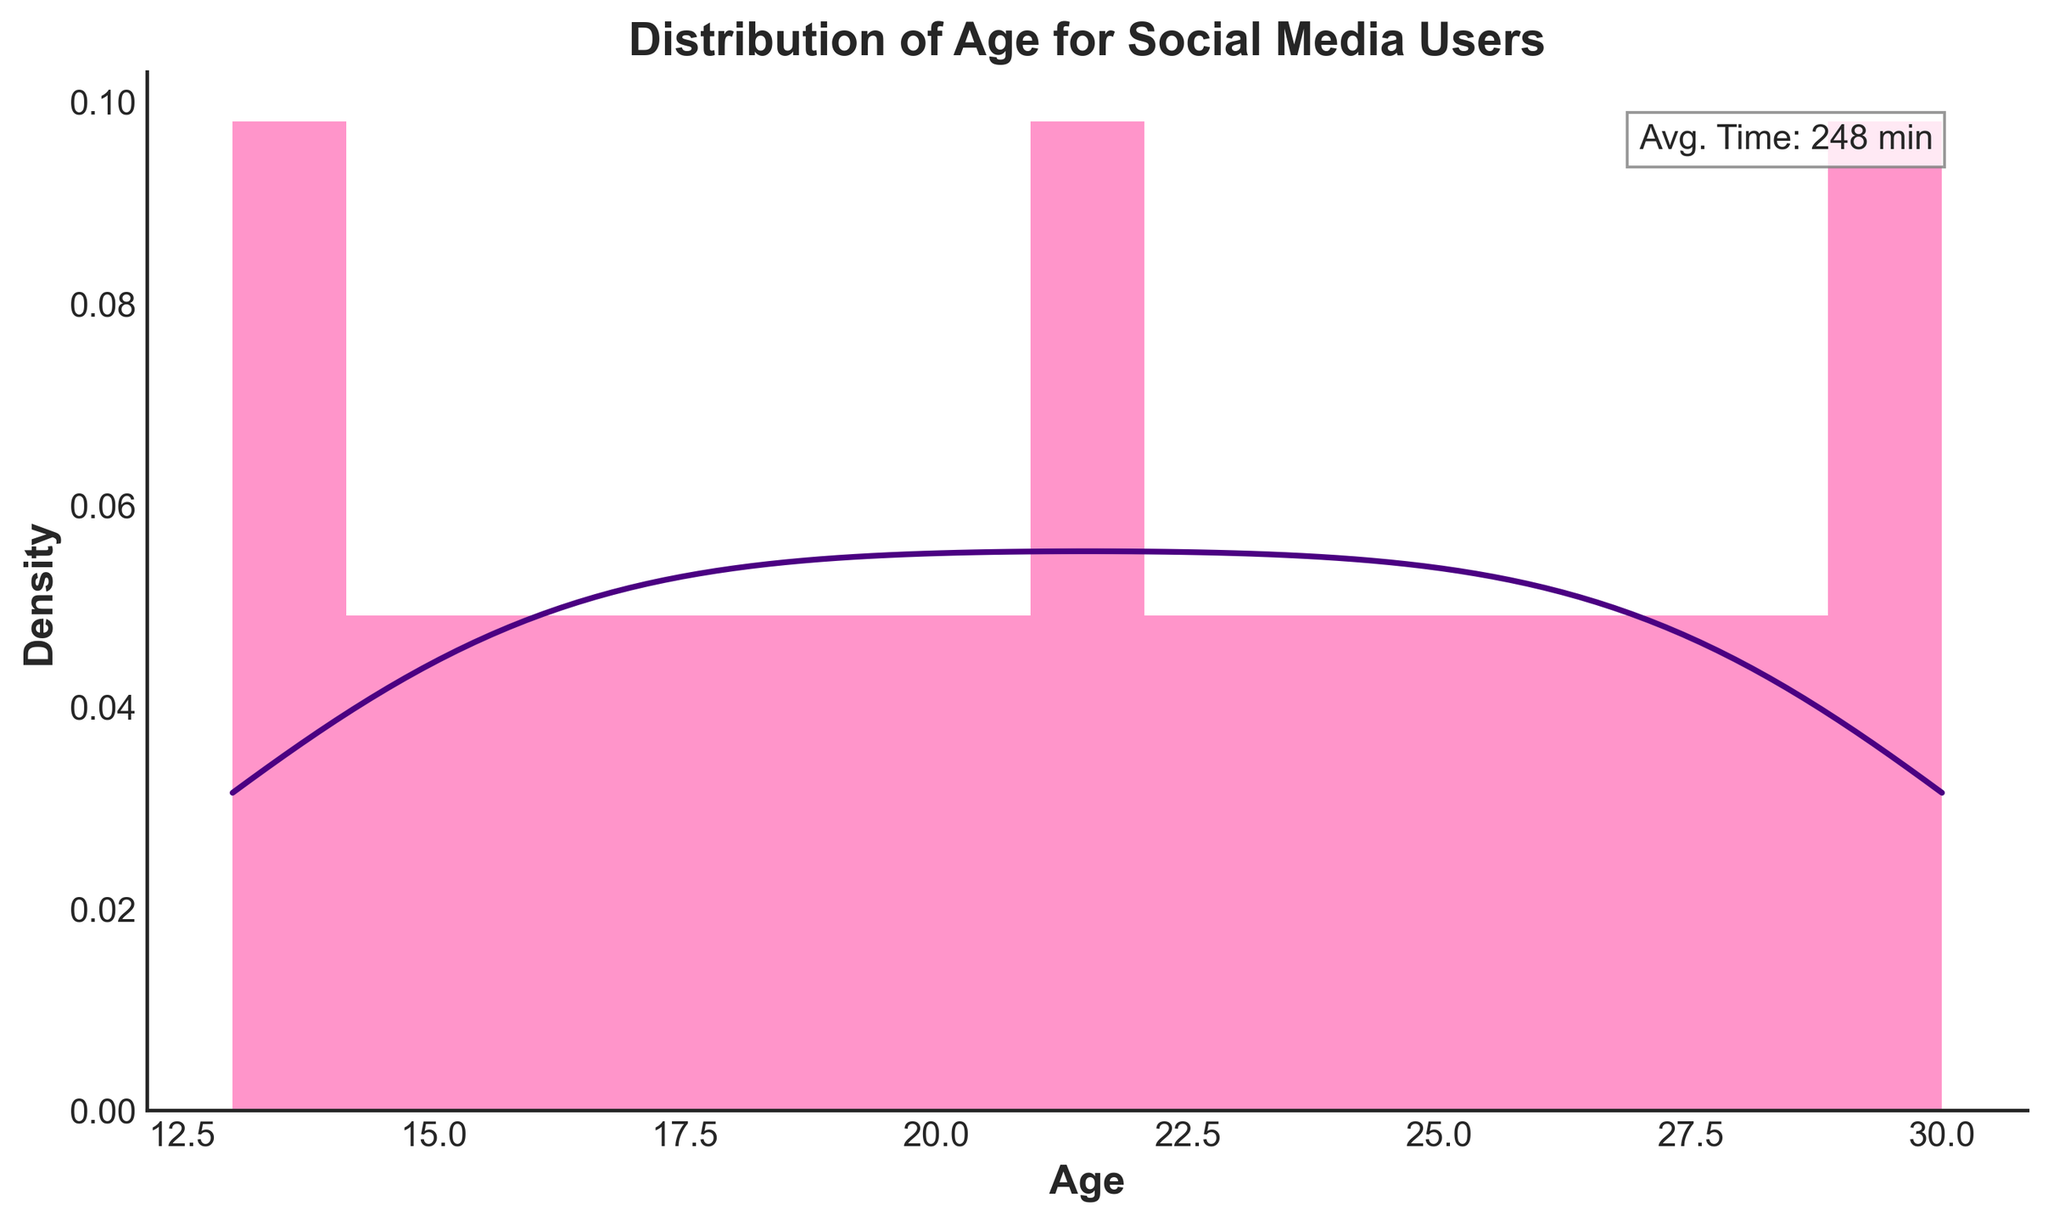What is the title of the plot? The title is displayed in bold at the top of the plot which reads "Distribution of Age for Social Media Users".
Answer: Distribution of Age for Social Media Users What is the average time spent on social media mentioned in the plot? The average daily time spent on social media is annotated in a text box within the plot area that states "Avg. Time: 247 min".
Answer: 247 min How many age groups are used to create the histogram? The histogram's bins represent age groups. There are 15 bars (bins), indicating 15 age groups.
Answer: 15 What is the color of the KDE (density curve) line? The KDE line is plotted in a color that appears dark purple on the plot.
Answer: Dark purple At what age range is the density of social media use the highest? The KDE line shows the highest peak in density. Observing the plot, the highest density is around the central age group, roughly between ages 20 to 25.
Answer: 20 to 25 Which age group shows the lowest density in use? By examining the KDE line, it is clear that the density is lowest at the extremities, around age 13 and age 30.
Answer: Around 13 and 30 Is the distribution of ages symmetrical, or does it skew? Observing the KDE curve, the distribution appears to be symmetrical, with a central peak and similar tails on both ends.
Answer: Symmetrical How does the ages' KDE curve compare to the histogram in terms of smoothness? The histogram shows discrete bins with gaps, while the KDE curve is smooth and continuous reflecting the underlying distribution of ages more clearly.
Answer: KDE curve is smoother What can be said about the variation in social media usage among different age groups? Observing the range from low to high density in the histogram and the KDE line, it can be inferred that younger and older age groups use social media less compared to the central age groups (20-25), which have the highest density indicating higher usage.
Answer: Higher usage in ages 20-25, lower in younger and older groups 